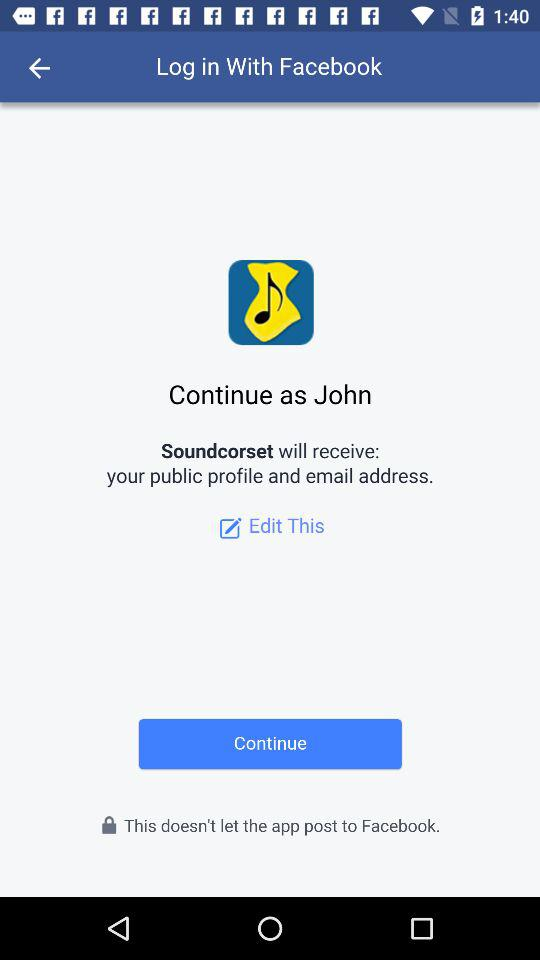What is the login name? The login name is "John". 